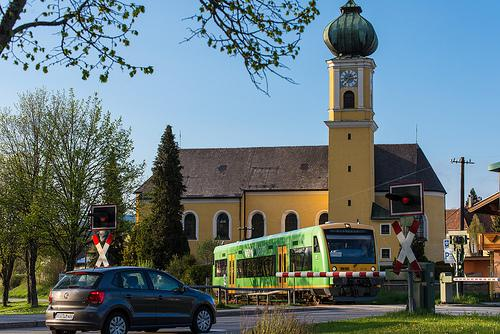Question: what color is the church?
Choices:
A. Red.
B. White.
C. Brown.
D. Yellow.
Answer with the letter. Answer: D Question: when was the photo taken?
Choices:
A. 2:35.
B. 4:30.
C. 12:10.
D. 8:25.
Answer with the letter. Answer: A Question: why is the car stopped?
Choices:
A. Because of the pedestrian.
B. Because of the dog.
C. Because of the train.
D. Because of the light.
Answer with the letter. Answer: C Question: who is visible in the scene?
Choices:
A. Everyone.
B. Women.
C. No one.
D. Men.
Answer with the letter. Answer: C 